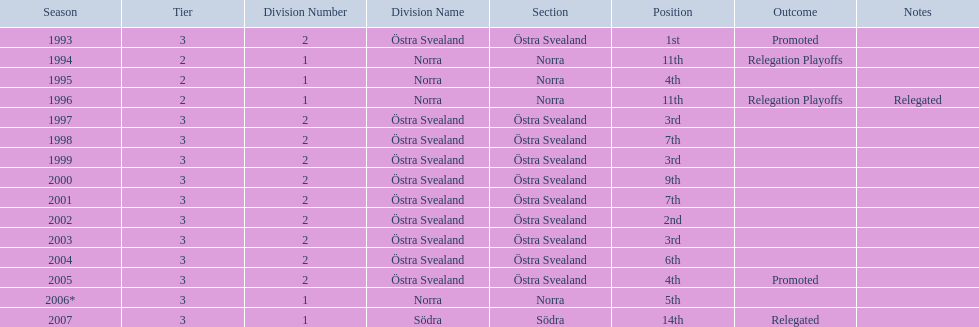What year is at least on the list? 2007. 